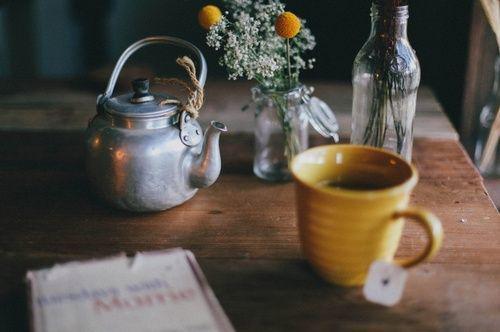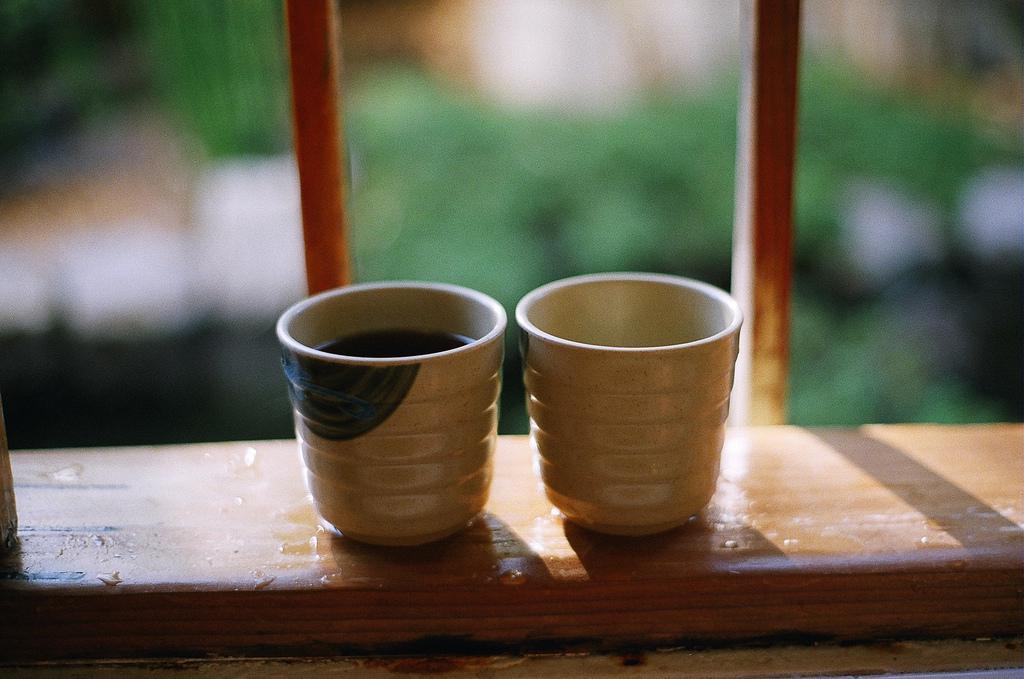The first image is the image on the left, the second image is the image on the right. Assess this claim about the two images: "The pair of cups in the right image have no handles.". Correct or not? Answer yes or no. Yes. The first image is the image on the left, the second image is the image on the right. Given the left and right images, does the statement "There are four cups of hot drinks, and two of them are sitting on plates." hold true? Answer yes or no. No. 